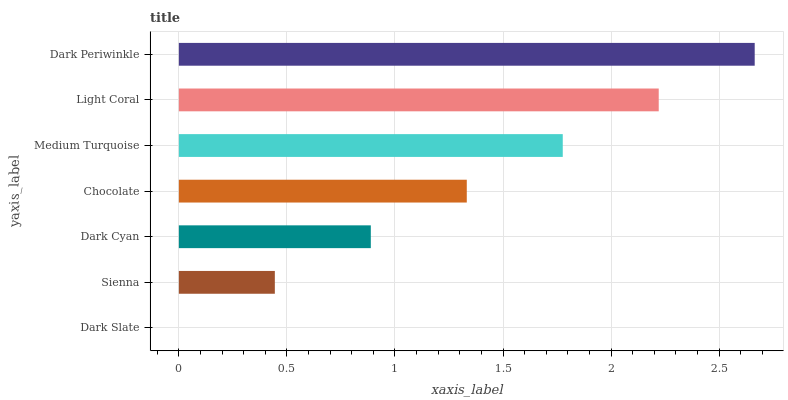Is Dark Slate the minimum?
Answer yes or no. Yes. Is Dark Periwinkle the maximum?
Answer yes or no. Yes. Is Sienna the minimum?
Answer yes or no. No. Is Sienna the maximum?
Answer yes or no. No. Is Sienna greater than Dark Slate?
Answer yes or no. Yes. Is Dark Slate less than Sienna?
Answer yes or no. Yes. Is Dark Slate greater than Sienna?
Answer yes or no. No. Is Sienna less than Dark Slate?
Answer yes or no. No. Is Chocolate the high median?
Answer yes or no. Yes. Is Chocolate the low median?
Answer yes or no. Yes. Is Light Coral the high median?
Answer yes or no. No. Is Medium Turquoise the low median?
Answer yes or no. No. 